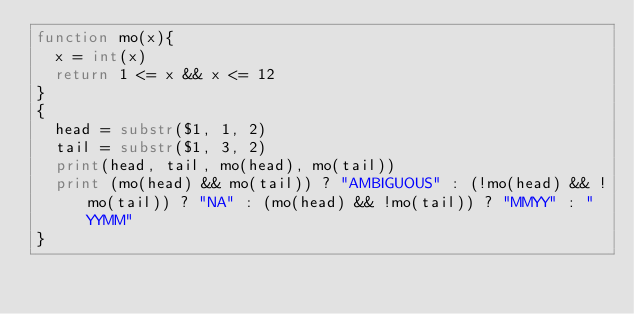Convert code to text. <code><loc_0><loc_0><loc_500><loc_500><_Awk_>function mo(x){
  x = int(x)
  return 1 <= x && x <= 12
}
{
  head = substr($1, 1, 2)
  tail = substr($1, 3, 2)
  print(head, tail, mo(head), mo(tail))
  print (mo(head) && mo(tail)) ? "AMBIGUOUS" : (!mo(head) && !mo(tail)) ? "NA" : (mo(head) && !mo(tail)) ? "MMYY" : "YYMM"
}
</code> 